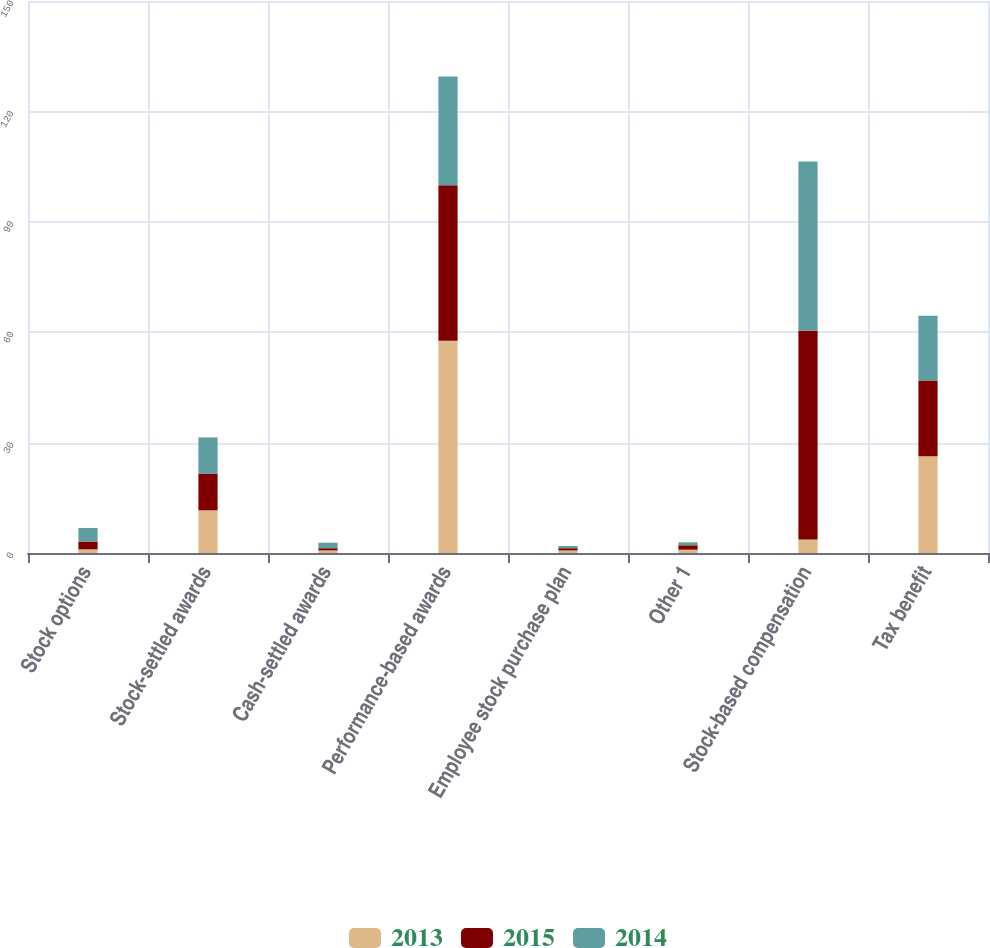Convert chart to OTSL. <chart><loc_0><loc_0><loc_500><loc_500><stacked_bar_chart><ecel><fcel>Stock options<fcel>Stock-settled awards<fcel>Cash-settled awards<fcel>Performance-based awards<fcel>Employee stock purchase plan<fcel>Other 1<fcel>Stock-based compensation<fcel>Tax benefit<nl><fcel>2013<fcel>1<fcel>11.6<fcel>0.7<fcel>57.7<fcel>0.7<fcel>0.9<fcel>3.7<fcel>26.3<nl><fcel>2015<fcel>2.1<fcel>10<fcel>0.6<fcel>42.2<fcel>0.6<fcel>1.2<fcel>56.7<fcel>20.6<nl><fcel>2014<fcel>3.7<fcel>9.8<fcel>1.5<fcel>29.6<fcel>0.6<fcel>0.8<fcel>46<fcel>17.6<nl></chart> 